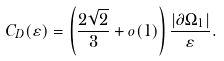<formula> <loc_0><loc_0><loc_500><loc_500>C _ { D } ( \varepsilon ) = \left ( \frac { 2 \sqrt { 2 } } 3 + o ( 1 ) \right ) \frac { | \partial { \Omega _ { 1 } } | } \varepsilon .</formula> 